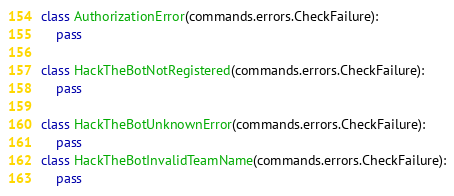<code> <loc_0><loc_0><loc_500><loc_500><_Python_>
class AuthorizationError(commands.errors.CheckFailure):
    pass

class HackTheBotNotRegistered(commands.errors.CheckFailure):
    pass

class HackTheBotUnknownError(commands.errors.CheckFailure):
    pass
class HackTheBotInvalidTeamName(commands.errors.CheckFailure):
    pass</code> 